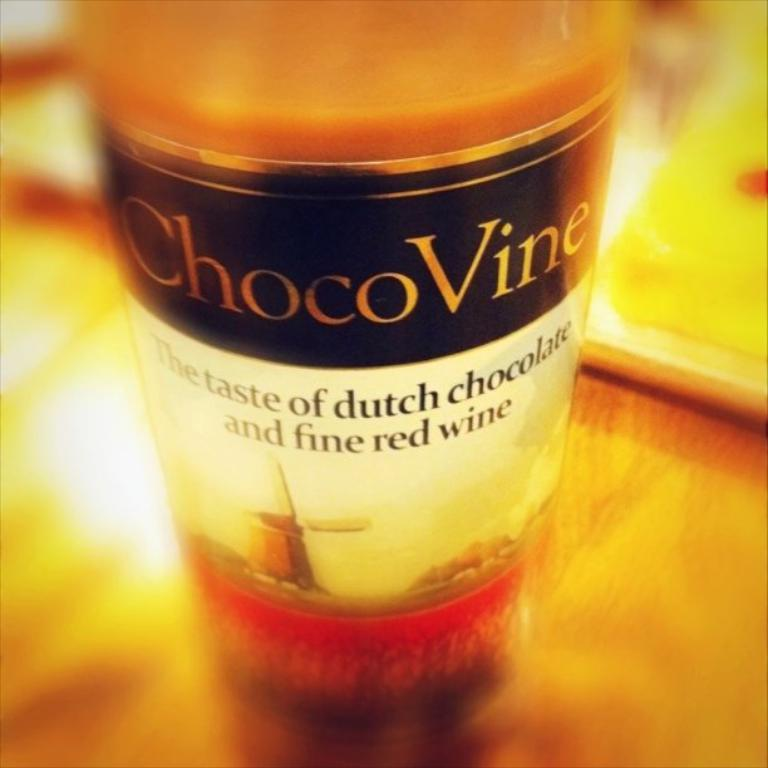<image>
Summarize the visual content of the image. A Chocovine Dutch Chocolate fine red wine on a table. 